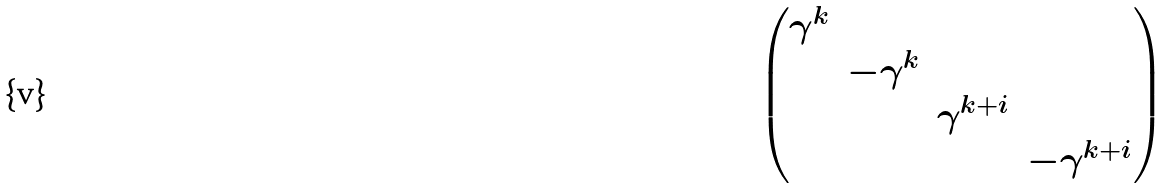<formula> <loc_0><loc_0><loc_500><loc_500>\begin{pmatrix} \gamma ^ { k } & & & \\ & - \gamma ^ { k } & & \\ & & \gamma ^ { k + i } & \\ & & & - \gamma ^ { k + i } \\ \end{pmatrix}</formula> 